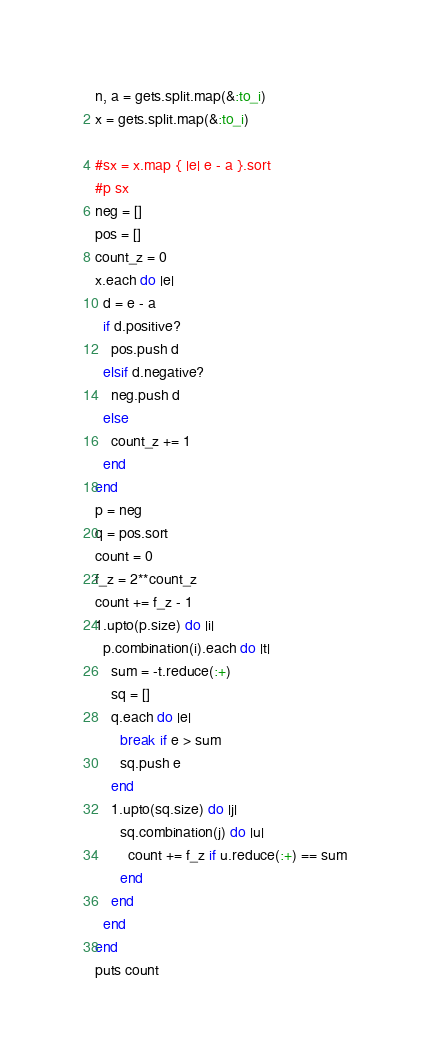Convert code to text. <code><loc_0><loc_0><loc_500><loc_500><_Ruby_>n, a = gets.split.map(&:to_i)
x = gets.split.map(&:to_i)

#sx = x.map { |e| e - a }.sort
#p sx
neg = []
pos = []
count_z = 0
x.each do |e|
  d = e - a
  if d.positive?
    pos.push d
  elsif d.negative?
    neg.push d
  else
    count_z += 1
  end
end
p = neg
q = pos.sort
count = 0
f_z = 2**count_z
count += f_z - 1
1.upto(p.size) do |i|
  p.combination(i).each do |t|
    sum = -t.reduce(:+)
    sq = []
    q.each do |e|
      break if e > sum
      sq.push e
    end
    1.upto(sq.size) do |j|
      sq.combination(j) do |u|
        count += f_z if u.reduce(:+) == sum
      end
    end
  end
end
puts count
</code> 